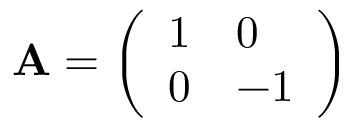<formula> <loc_0><loc_0><loc_500><loc_500>A = { \left ( \begin{array} { l l } { 1 } & { 0 } \\ { 0 } & { - 1 } \end{array} \right ) }</formula> 